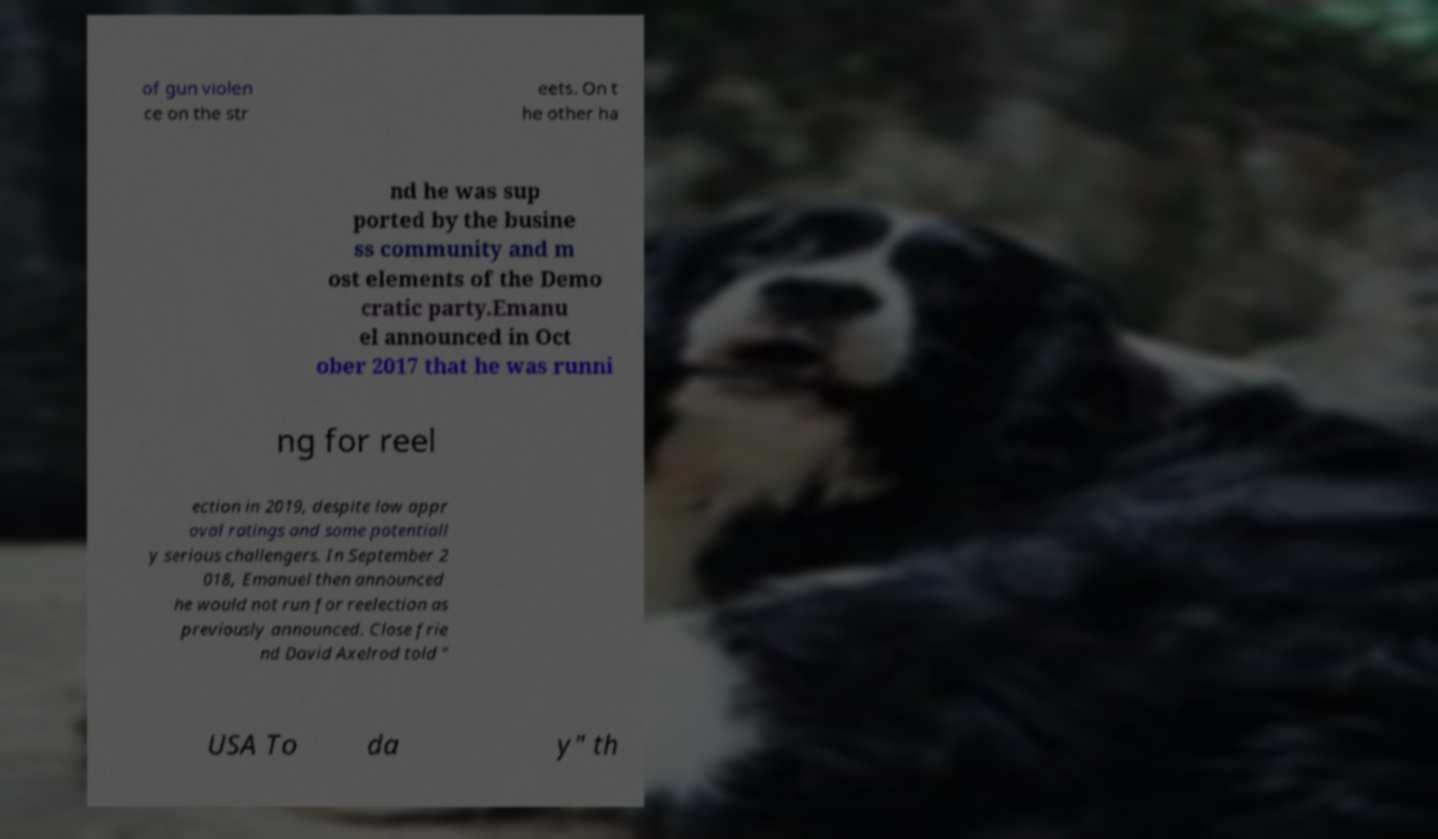Please read and relay the text visible in this image. What does it say? of gun violen ce on the str eets. On t he other ha nd he was sup ported by the busine ss community and m ost elements of the Demo cratic party.Emanu el announced in Oct ober 2017 that he was runni ng for reel ection in 2019, despite low appr oval ratings and some potentiall y serious challengers. In September 2 018, Emanuel then announced he would not run for reelection as previously announced. Close frie nd David Axelrod told " USA To da y" th 